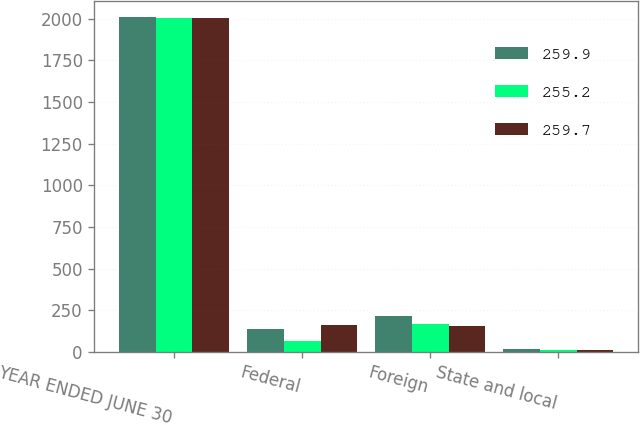Convert chart to OTSL. <chart><loc_0><loc_0><loc_500><loc_500><stacked_bar_chart><ecel><fcel>YEAR ENDED JUNE 30<fcel>Federal<fcel>Foreign<fcel>State and local<nl><fcel>259.9<fcel>2008<fcel>141.4<fcel>214.1<fcel>20<nl><fcel>255.2<fcel>2007<fcel>66.6<fcel>166.7<fcel>12<nl><fcel>259.7<fcel>2006<fcel>164.3<fcel>158.2<fcel>11.5<nl></chart> 